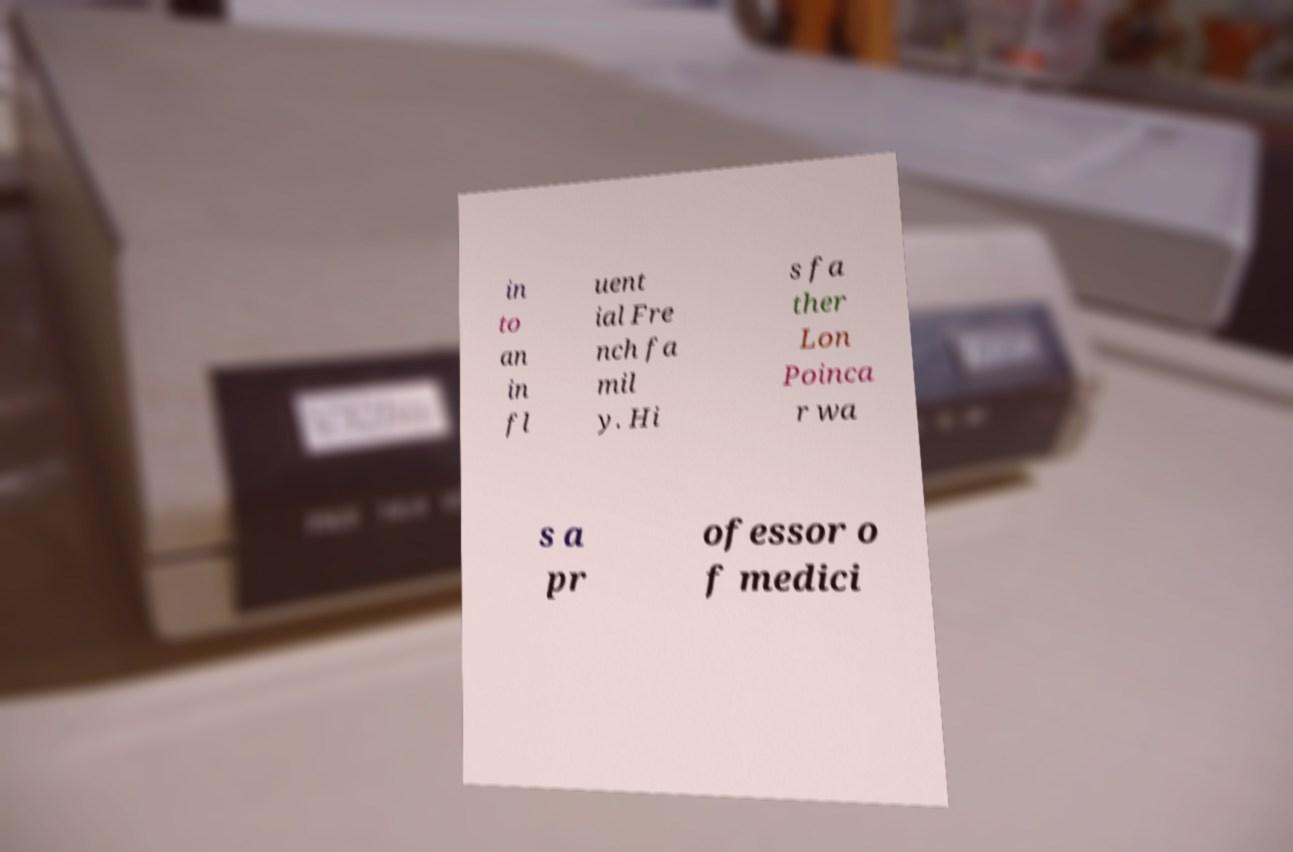What messages or text are displayed in this image? I need them in a readable, typed format. in to an in fl uent ial Fre nch fa mil y. Hi s fa ther Lon Poinca r wa s a pr ofessor o f medici 